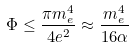<formula> <loc_0><loc_0><loc_500><loc_500>\Phi \leq \frac { \pi m _ { e } ^ { 4 } } { 4 e ^ { 2 } } \approx \frac { m _ { e } ^ { 4 } } { 1 6 \alpha }</formula> 